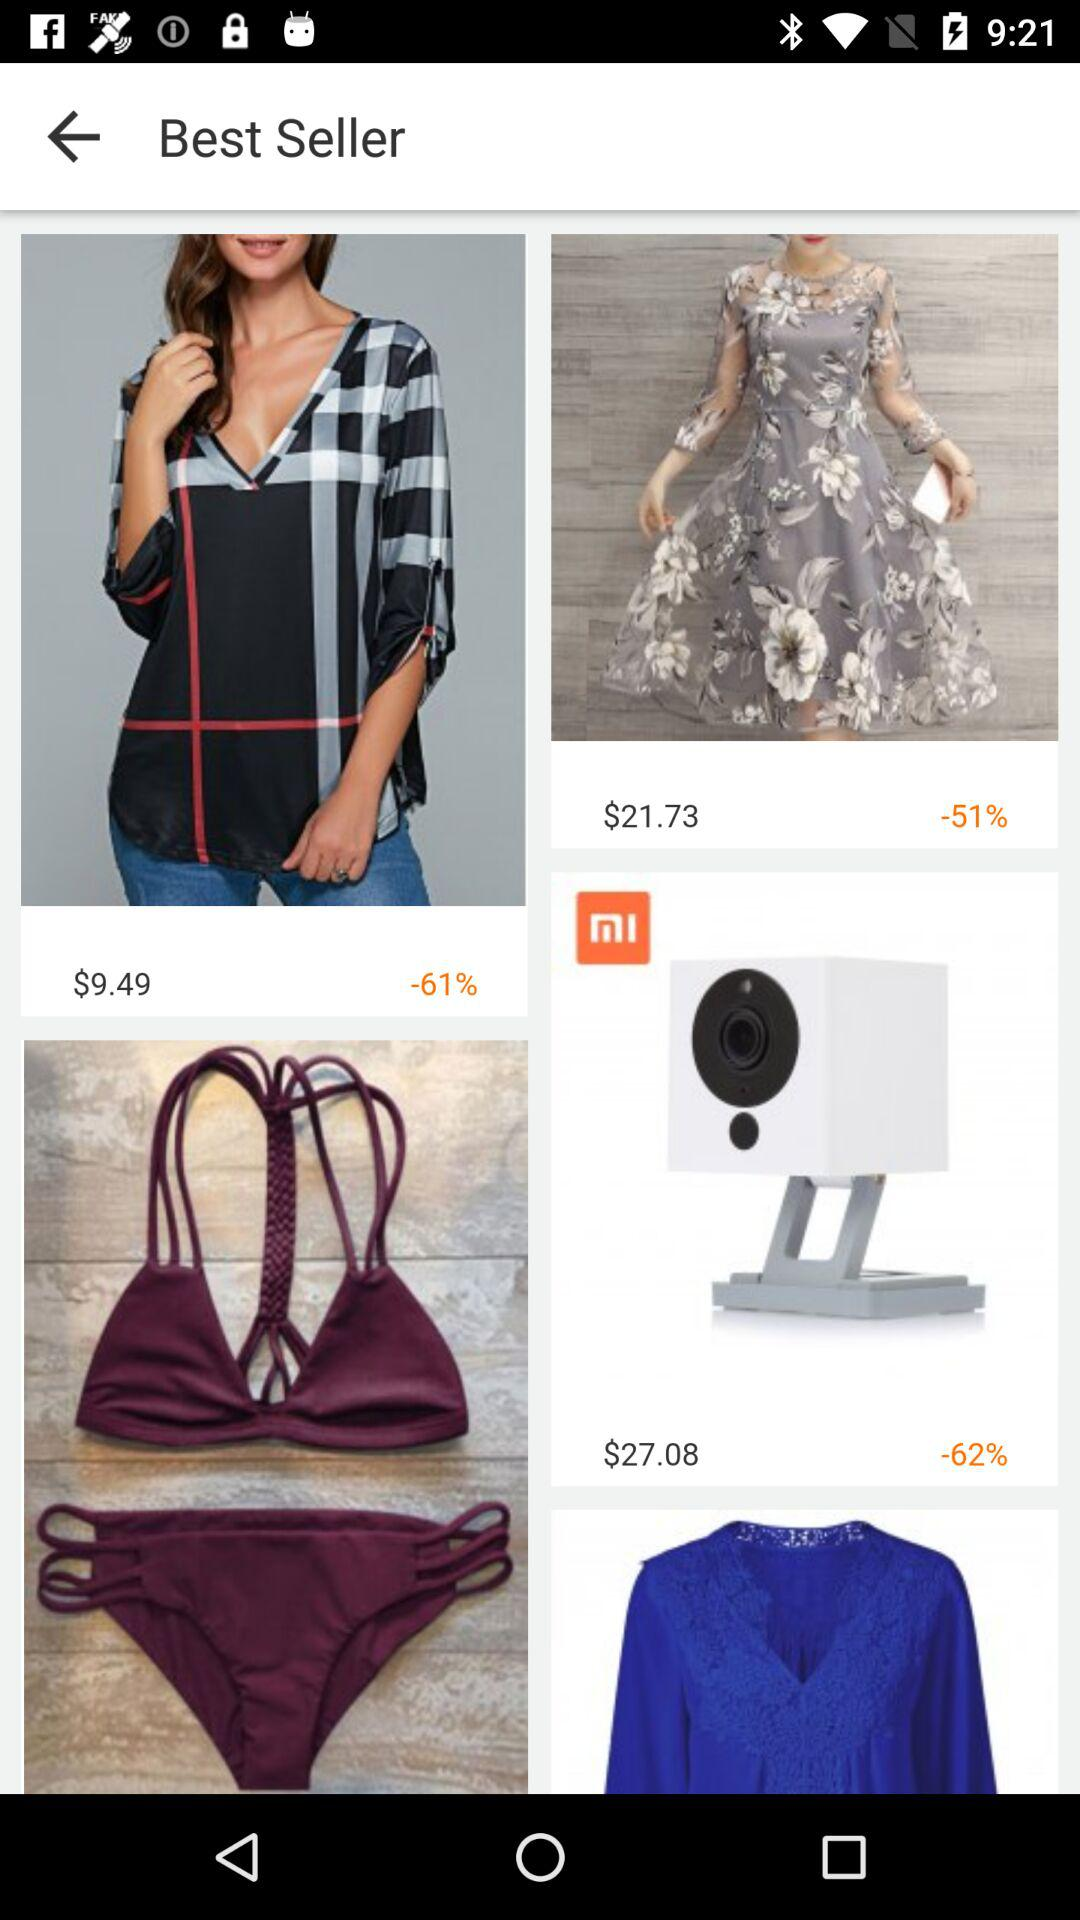What is the cost of the "Mi Camera"? The cost of the "Mi Camera" is $27.08. 